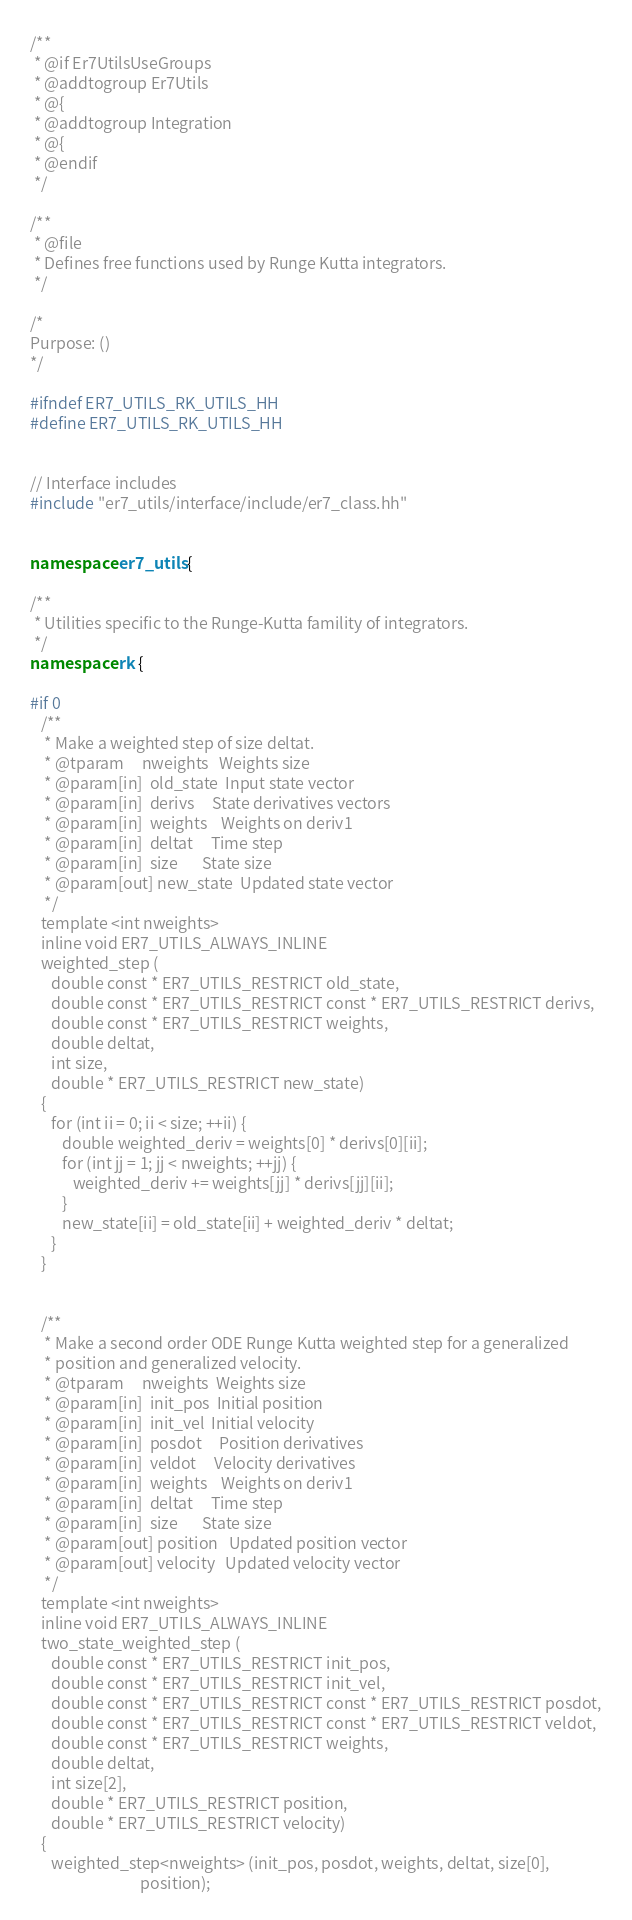<code> <loc_0><loc_0><loc_500><loc_500><_C++_>/**
 * @if Er7UtilsUseGroups
 * @addtogroup Er7Utils
 * @{
 * @addtogroup Integration
 * @{
 * @endif
 */

/**
 * @file
 * Defines free functions used by Runge Kutta integrators.
 */

/*
Purpose: ()
*/

#ifndef ER7_UTILS_RK_UTILS_HH
#define ER7_UTILS_RK_UTILS_HH


// Interface includes
#include "er7_utils/interface/include/er7_class.hh"


namespace er7_utils {

/**
 * Utilities specific to the Runge-Kutta famility of integrators.
 */
namespace rk {

#if 0
   /**
    * Make a weighted step of size deltat.
    * @tparam     nweights   Weights size
    * @param[in]  old_state  Input state vector
    * @param[in]  derivs     State derivatives vectors
    * @param[in]  weights    Weights on deriv1
    * @param[in]  deltat     Time step
    * @param[in]  size       State size
    * @param[out] new_state  Updated state vector
    */
   template <int nweights>
   inline void ER7_UTILS_ALWAYS_INLINE
   weighted_step (
      double const * ER7_UTILS_RESTRICT old_state,
      double const * ER7_UTILS_RESTRICT const * ER7_UTILS_RESTRICT derivs,
      double const * ER7_UTILS_RESTRICT weights,
      double deltat,
      int size,
      double * ER7_UTILS_RESTRICT new_state)
   {
      for (int ii = 0; ii < size; ++ii) {
         double weighted_deriv = weights[0] * derivs[0][ii];
         for (int jj = 1; jj < nweights; ++jj) {
            weighted_deriv += weights[jj] * derivs[jj][ii];
         }
         new_state[ii] = old_state[ii] + weighted_deriv * deltat;
      }
   }


   /**
    * Make a second order ODE Runge Kutta weighted step for a generalized
    * position and generalized velocity.
    * @tparam     nweights  Weights size
    * @param[in]  init_pos  Initial position
    * @param[in]  init_vel  Initial velocity
    * @param[in]  posdot     Position derivatives
    * @param[in]  veldot     Velocity derivatives
    * @param[in]  weights    Weights on deriv1
    * @param[in]  deltat     Time step
    * @param[in]  size       State size
    * @param[out] position   Updated position vector
    * @param[out] velocity   Updated velocity vector
    */
   template <int nweights>
   inline void ER7_UTILS_ALWAYS_INLINE
   two_state_weighted_step (
      double const * ER7_UTILS_RESTRICT init_pos,
      double const * ER7_UTILS_RESTRICT init_vel,
      double const * ER7_UTILS_RESTRICT const * ER7_UTILS_RESTRICT posdot,
      double const * ER7_UTILS_RESTRICT const * ER7_UTILS_RESTRICT veldot,
      double const * ER7_UTILS_RESTRICT weights,
      double deltat,
      int size[2],
      double * ER7_UTILS_RESTRICT position,
      double * ER7_UTILS_RESTRICT velocity)
   {
      weighted_step<nweights> (init_pos, posdot, weights, deltat, size[0],
                               position);</code> 